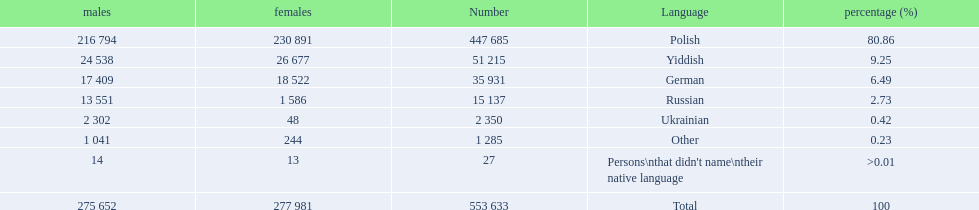What was the highest percentage of one language spoken by the plock governorate? 80.86. What language was spoken by 80.86 percent of the people? Polish. 